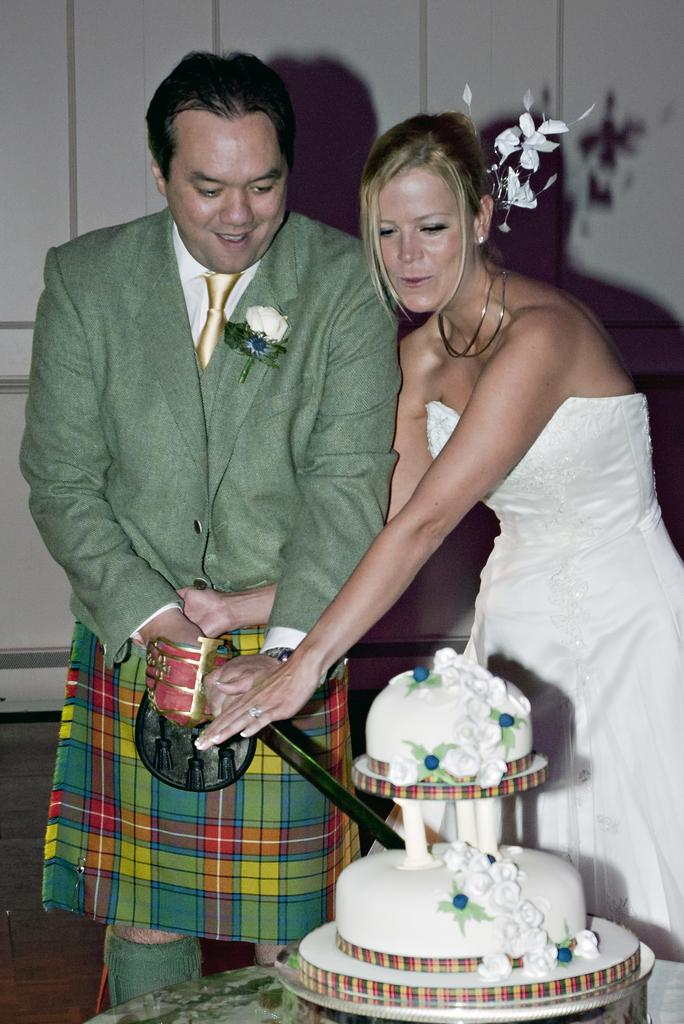What are the people in the image wearing? The persons in the image are wearing clothes. Can you describe the person on the left side of the image? The person on the left side of the image is holding a sword with his hands. What is located at the bottom of the image? There is a cake at the bottom of the image. What type of crime is being committed in the image? There is no indication of a crime being committed in the image. How does the jelly interact with the cake in the image? There is no jelly present in the image; it only features a cake. 